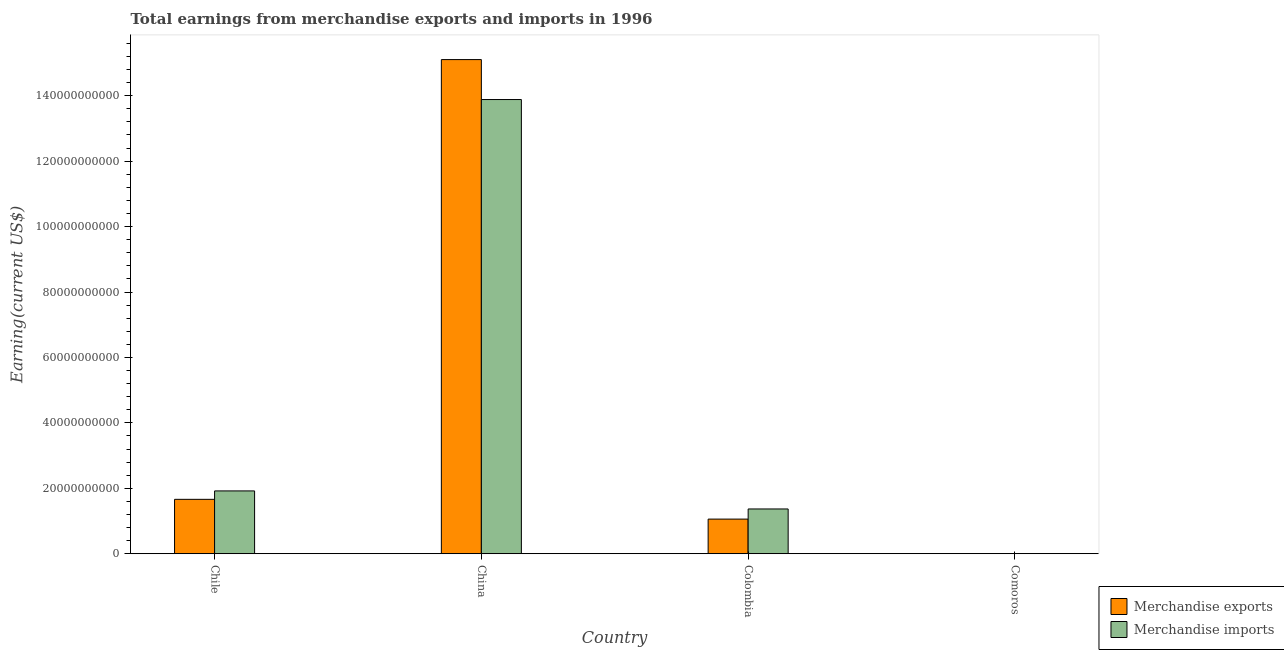Are the number of bars per tick equal to the number of legend labels?
Your response must be concise. Yes. Are the number of bars on each tick of the X-axis equal?
Your response must be concise. Yes. How many bars are there on the 3rd tick from the left?
Your answer should be compact. 2. What is the label of the 4th group of bars from the left?
Your answer should be compact. Comoros. In how many cases, is the number of bars for a given country not equal to the number of legend labels?
Your response must be concise. 0. What is the earnings from merchandise imports in Chile?
Keep it short and to the point. 1.92e+1. Across all countries, what is the maximum earnings from merchandise exports?
Offer a terse response. 1.51e+11. Across all countries, what is the minimum earnings from merchandise imports?
Make the answer very short. 5.70e+07. In which country was the earnings from merchandise imports minimum?
Your answer should be compact. Comoros. What is the total earnings from merchandise imports in the graph?
Ensure brevity in your answer.  1.72e+11. What is the difference between the earnings from merchandise imports in Chile and that in China?
Provide a short and direct response. -1.20e+11. What is the difference between the earnings from merchandise imports in Comoros and the earnings from merchandise exports in Chile?
Keep it short and to the point. -1.66e+1. What is the average earnings from merchandise imports per country?
Your answer should be compact. 4.29e+1. What is the difference between the earnings from merchandise exports and earnings from merchandise imports in China?
Your response must be concise. 1.22e+1. In how many countries, is the earnings from merchandise imports greater than 80000000000 US$?
Provide a short and direct response. 1. What is the ratio of the earnings from merchandise imports in Chile to that in China?
Your answer should be compact. 0.14. What is the difference between the highest and the second highest earnings from merchandise exports?
Provide a short and direct response. 1.34e+11. What is the difference between the highest and the lowest earnings from merchandise imports?
Make the answer very short. 1.39e+11. In how many countries, is the earnings from merchandise exports greater than the average earnings from merchandise exports taken over all countries?
Give a very brief answer. 1. Is the sum of the earnings from merchandise imports in China and Comoros greater than the maximum earnings from merchandise exports across all countries?
Your answer should be very brief. No. What does the 2nd bar from the left in Comoros represents?
Your answer should be very brief. Merchandise imports. How many countries are there in the graph?
Keep it short and to the point. 4. What is the difference between two consecutive major ticks on the Y-axis?
Ensure brevity in your answer.  2.00e+1. Are the values on the major ticks of Y-axis written in scientific E-notation?
Ensure brevity in your answer.  No. Where does the legend appear in the graph?
Ensure brevity in your answer.  Bottom right. What is the title of the graph?
Give a very brief answer. Total earnings from merchandise exports and imports in 1996. Does "Total Population" appear as one of the legend labels in the graph?
Your answer should be compact. No. What is the label or title of the Y-axis?
Ensure brevity in your answer.  Earning(current US$). What is the Earning(current US$) of Merchandise exports in Chile?
Provide a short and direct response. 1.66e+1. What is the Earning(current US$) of Merchandise imports in Chile?
Your answer should be compact. 1.92e+1. What is the Earning(current US$) of Merchandise exports in China?
Offer a terse response. 1.51e+11. What is the Earning(current US$) of Merchandise imports in China?
Keep it short and to the point. 1.39e+11. What is the Earning(current US$) of Merchandise exports in Colombia?
Your answer should be very brief. 1.06e+1. What is the Earning(current US$) in Merchandise imports in Colombia?
Provide a succinct answer. 1.37e+1. What is the Earning(current US$) of Merchandise exports in Comoros?
Your answer should be very brief. 6.14e+06. What is the Earning(current US$) in Merchandise imports in Comoros?
Your answer should be compact. 5.70e+07. Across all countries, what is the maximum Earning(current US$) of Merchandise exports?
Your answer should be compact. 1.51e+11. Across all countries, what is the maximum Earning(current US$) of Merchandise imports?
Offer a terse response. 1.39e+11. Across all countries, what is the minimum Earning(current US$) of Merchandise exports?
Offer a terse response. 6.14e+06. Across all countries, what is the minimum Earning(current US$) of Merchandise imports?
Provide a succinct answer. 5.70e+07. What is the total Earning(current US$) of Merchandise exports in the graph?
Make the answer very short. 1.78e+11. What is the total Earning(current US$) in Merchandise imports in the graph?
Provide a short and direct response. 1.72e+11. What is the difference between the Earning(current US$) in Merchandise exports in Chile and that in China?
Make the answer very short. -1.34e+11. What is the difference between the Earning(current US$) of Merchandise imports in Chile and that in China?
Your answer should be compact. -1.20e+11. What is the difference between the Earning(current US$) of Merchandise exports in Chile and that in Colombia?
Ensure brevity in your answer.  6.04e+09. What is the difference between the Earning(current US$) in Merchandise imports in Chile and that in Colombia?
Keep it short and to the point. 5.52e+09. What is the difference between the Earning(current US$) in Merchandise exports in Chile and that in Comoros?
Your answer should be very brief. 1.66e+1. What is the difference between the Earning(current US$) of Merchandise imports in Chile and that in Comoros?
Make the answer very short. 1.91e+1. What is the difference between the Earning(current US$) in Merchandise exports in China and that in Colombia?
Your answer should be very brief. 1.40e+11. What is the difference between the Earning(current US$) in Merchandise imports in China and that in Colombia?
Your answer should be very brief. 1.25e+11. What is the difference between the Earning(current US$) of Merchandise exports in China and that in Comoros?
Offer a very short reply. 1.51e+11. What is the difference between the Earning(current US$) in Merchandise imports in China and that in Comoros?
Your response must be concise. 1.39e+11. What is the difference between the Earning(current US$) of Merchandise exports in Colombia and that in Comoros?
Provide a short and direct response. 1.06e+1. What is the difference between the Earning(current US$) of Merchandise imports in Colombia and that in Comoros?
Your response must be concise. 1.36e+1. What is the difference between the Earning(current US$) of Merchandise exports in Chile and the Earning(current US$) of Merchandise imports in China?
Make the answer very short. -1.22e+11. What is the difference between the Earning(current US$) of Merchandise exports in Chile and the Earning(current US$) of Merchandise imports in Colombia?
Make the answer very short. 2.94e+09. What is the difference between the Earning(current US$) in Merchandise exports in Chile and the Earning(current US$) in Merchandise imports in Comoros?
Your answer should be compact. 1.66e+1. What is the difference between the Earning(current US$) of Merchandise exports in China and the Earning(current US$) of Merchandise imports in Colombia?
Your answer should be very brief. 1.37e+11. What is the difference between the Earning(current US$) in Merchandise exports in China and the Earning(current US$) in Merchandise imports in Comoros?
Your response must be concise. 1.51e+11. What is the difference between the Earning(current US$) of Merchandise exports in Colombia and the Earning(current US$) of Merchandise imports in Comoros?
Provide a short and direct response. 1.05e+1. What is the average Earning(current US$) in Merchandise exports per country?
Your response must be concise. 4.46e+1. What is the average Earning(current US$) in Merchandise imports per country?
Make the answer very short. 4.29e+1. What is the difference between the Earning(current US$) in Merchandise exports and Earning(current US$) in Merchandise imports in Chile?
Provide a short and direct response. -2.57e+09. What is the difference between the Earning(current US$) in Merchandise exports and Earning(current US$) in Merchandise imports in China?
Ensure brevity in your answer.  1.22e+1. What is the difference between the Earning(current US$) in Merchandise exports and Earning(current US$) in Merchandise imports in Colombia?
Provide a succinct answer. -3.10e+09. What is the difference between the Earning(current US$) of Merchandise exports and Earning(current US$) of Merchandise imports in Comoros?
Offer a very short reply. -5.09e+07. What is the ratio of the Earning(current US$) of Merchandise exports in Chile to that in China?
Give a very brief answer. 0.11. What is the ratio of the Earning(current US$) in Merchandise imports in Chile to that in China?
Make the answer very short. 0.14. What is the ratio of the Earning(current US$) in Merchandise exports in Chile to that in Colombia?
Ensure brevity in your answer.  1.57. What is the ratio of the Earning(current US$) of Merchandise imports in Chile to that in Colombia?
Make the answer very short. 1.4. What is the ratio of the Earning(current US$) in Merchandise exports in Chile to that in Comoros?
Offer a terse response. 2707.98. What is the ratio of the Earning(current US$) of Merchandise imports in Chile to that in Comoros?
Your answer should be compact. 336.82. What is the ratio of the Earning(current US$) of Merchandise exports in China to that in Colombia?
Your answer should be very brief. 14.27. What is the ratio of the Earning(current US$) in Merchandise imports in China to that in Colombia?
Keep it short and to the point. 10.15. What is the ratio of the Earning(current US$) of Merchandise exports in China to that in Comoros?
Your answer should be compact. 2.46e+04. What is the ratio of the Earning(current US$) of Merchandise imports in China to that in Comoros?
Your answer should be compact. 2435.67. What is the ratio of the Earning(current US$) in Merchandise exports in Colombia to that in Comoros?
Ensure brevity in your answer.  1724.27. What is the ratio of the Earning(current US$) of Merchandise imports in Colombia to that in Comoros?
Your response must be concise. 240.05. What is the difference between the highest and the second highest Earning(current US$) of Merchandise exports?
Offer a very short reply. 1.34e+11. What is the difference between the highest and the second highest Earning(current US$) of Merchandise imports?
Ensure brevity in your answer.  1.20e+11. What is the difference between the highest and the lowest Earning(current US$) in Merchandise exports?
Your answer should be very brief. 1.51e+11. What is the difference between the highest and the lowest Earning(current US$) in Merchandise imports?
Provide a short and direct response. 1.39e+11. 